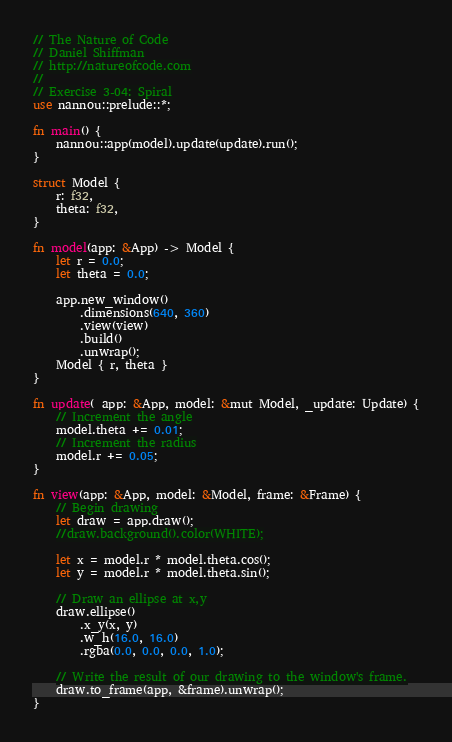<code> <loc_0><loc_0><loc_500><loc_500><_Rust_>// The Nature of Code
// Daniel Shiffman
// http://natureofcode.com
//
// Exercise 3-04: Spiral
use nannou::prelude::*;

fn main() {
    nannou::app(model).update(update).run();
}

struct Model {
    r: f32,
    theta: f32,
}

fn model(app: &App) -> Model {
    let r = 0.0;
    let theta = 0.0;

    app.new_window()
        .dimensions(640, 360)
        .view(view)
        .build()
        .unwrap();
    Model { r, theta }
}

fn update(_app: &App, model: &mut Model, _update: Update) {
    // Increment the angle
    model.theta += 0.01;
    // Increment the radius
    model.r += 0.05;
}

fn view(app: &App, model: &Model, frame: &Frame) {
    // Begin drawing
    let draw = app.draw();
    //draw.background().color(WHITE);

    let x = model.r * model.theta.cos();
    let y = model.r * model.theta.sin();

    // Draw an ellipse at x,y
    draw.ellipse()
        .x_y(x, y)
        .w_h(16.0, 16.0)
        .rgba(0.0, 0.0, 0.0, 1.0);

    // Write the result of our drawing to the window's frame.
    draw.to_frame(app, &frame).unwrap();
}
</code> 